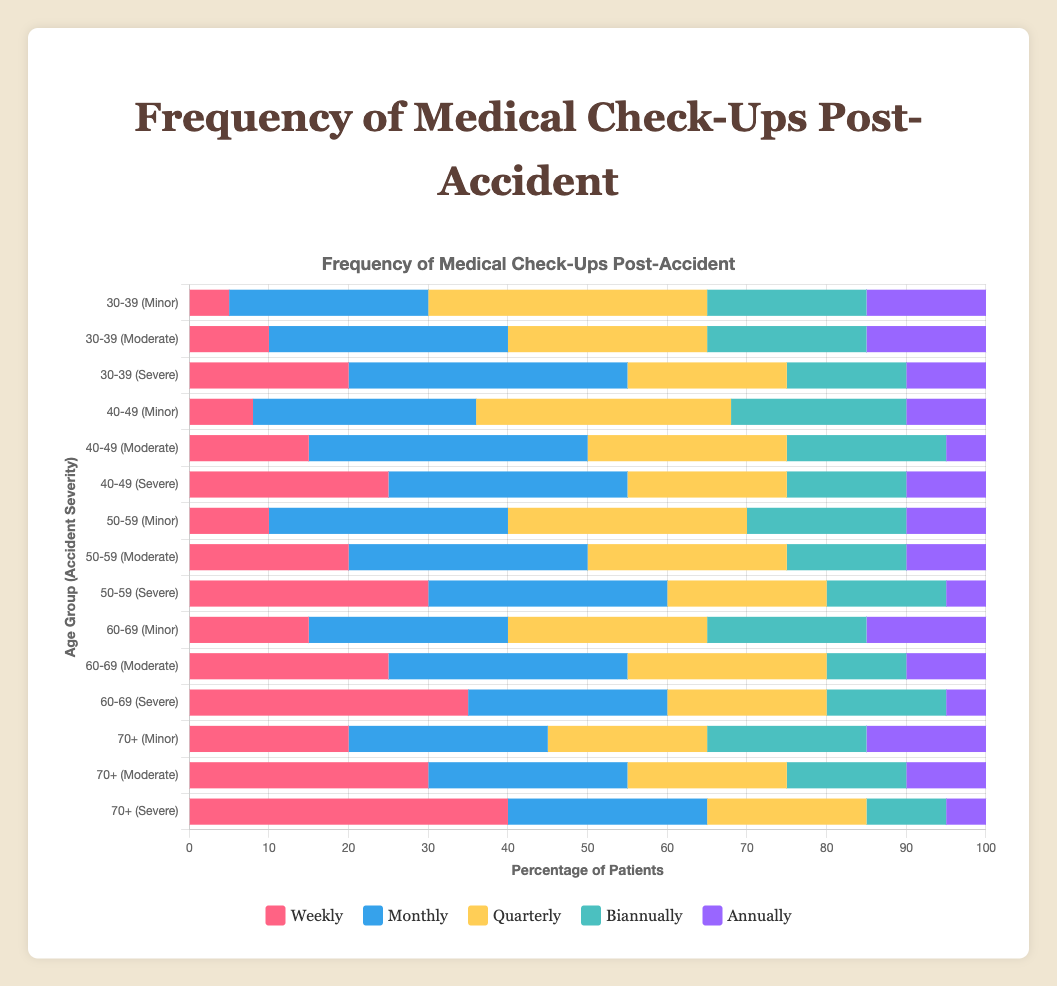Which age group with moderate accident severity has the highest percentage of weekly check-ups? To analyze this, we first locate and compare the weekly check-ups data for "Moderate" accident severity across all age groups. The values are 10 (30-39), 15 (40-49), 20 (50-59), 25 (60-69), and 30 (70+). From these values, the age group “70+” has the highest percentage of weekly check-ups at 30%.
Answer: 70+ Comparing minor accidents, which age group has more annual check-ups: 60-69 or 70+? We locate the annual check-ups for both age groups under "Minor" severity. The values are 15 (60-69) and 15 (70+). Both age groups have the same percentage of annual check-ups at 15%.
Answer: Equal What is the total percentage of biannual check-ups for severe accidents in the age group 50-59? For this, we refer to the figures for biannual check-ups under "Severe" for the age group 50-59, which is 15. Since this is the only value needed, the total percentage of biannual check-ups for this severe accident age group is 15%.
Answer: 15% How many age groups with minor accident severity have more than 15% weekly check-ups? We check the "Minor" severity category for each age group's weekly check-up values: 5 (30-39), 8 (40-49), 10 (50-59), 15 (60-69), and 20 (70+). Only the age group "70+" has a value greater than 15%.
Answer: 1 In the 40-49 age group, which frequency of check-ups comprises the greatest percentage for moderate severity accidents? We examine each frequency's values for "Moderate" under the 40-49 age group: 15 (weekly), 35 (monthly), 25 (quarterly), 20 (biannually), and 5 (annually). The "monthly" check-ups have the highest value of 35%.
Answer: Monthly What is the most common frequency of check-ups for severe accidents in the age group 70+? We locate the values for severe accidents in the 70+ age group for each frequency: 40 (weekly), 25 (monthly), 20 (quarterly), 10 (biannually), and 5 (annually). The "weekly" check-ups, with a value of 40, is the highest.
Answer: Weekly Which severity level in the age group 50-59 has the least percentage of annual check-ups? We compare the annual check-up values for each severity level within the 50-59 age group: Minor (10), Moderate (10), and Severe (5). "Severe" accidents have the least percentage of annual check-ups at 5%.
Answer: Severe What is the average percentage of quarterly check-ups for moderate severity accidents across all age groups? To find the average, sum up the quarterly check-up percentages for moderate accidents across all age groups: 25 (30-39), 25 (40-49), 25 (50-59), 25 (60-69), and 20 (70+). The total is 120. Divide by the number of age groups (5): 120 / 5 = 24%.
Answer: 24% In the 30-39 age group, are there more biannual check-ups for minor or severe accidents? We compare biannual check-ups for "Minor" and "Severe" categories within the 30-39 age group, which are 20 (Minor) and 15 (Severe). The "Minor" category has more biannual check-ups at 20%.
Answer: Minor What is the difference in the percentage of monthly check-ups between moderate and severe accidents for the 60-69 age group? First, get the monthly check-up values: Moderate (30) and Severe (25). Subtract these values: 30 - 25 = 5%. The difference is 5%.
Answer: 5% 